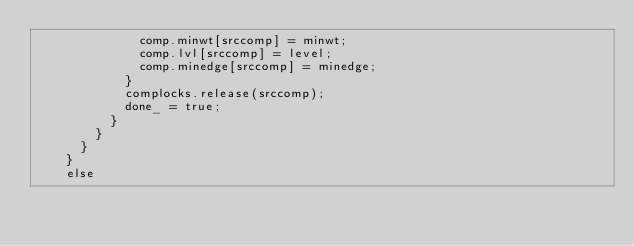<code> <loc_0><loc_0><loc_500><loc_500><_Cuda_>              comp.minwt[srccomp] = minwt;
              comp.lvl[srccomp] = level;
              comp.minedge[srccomp] = minedge;
            }
            complocks.release(srccomp);
            done_ = true;
          }
        }
      }
    }
    else</code> 